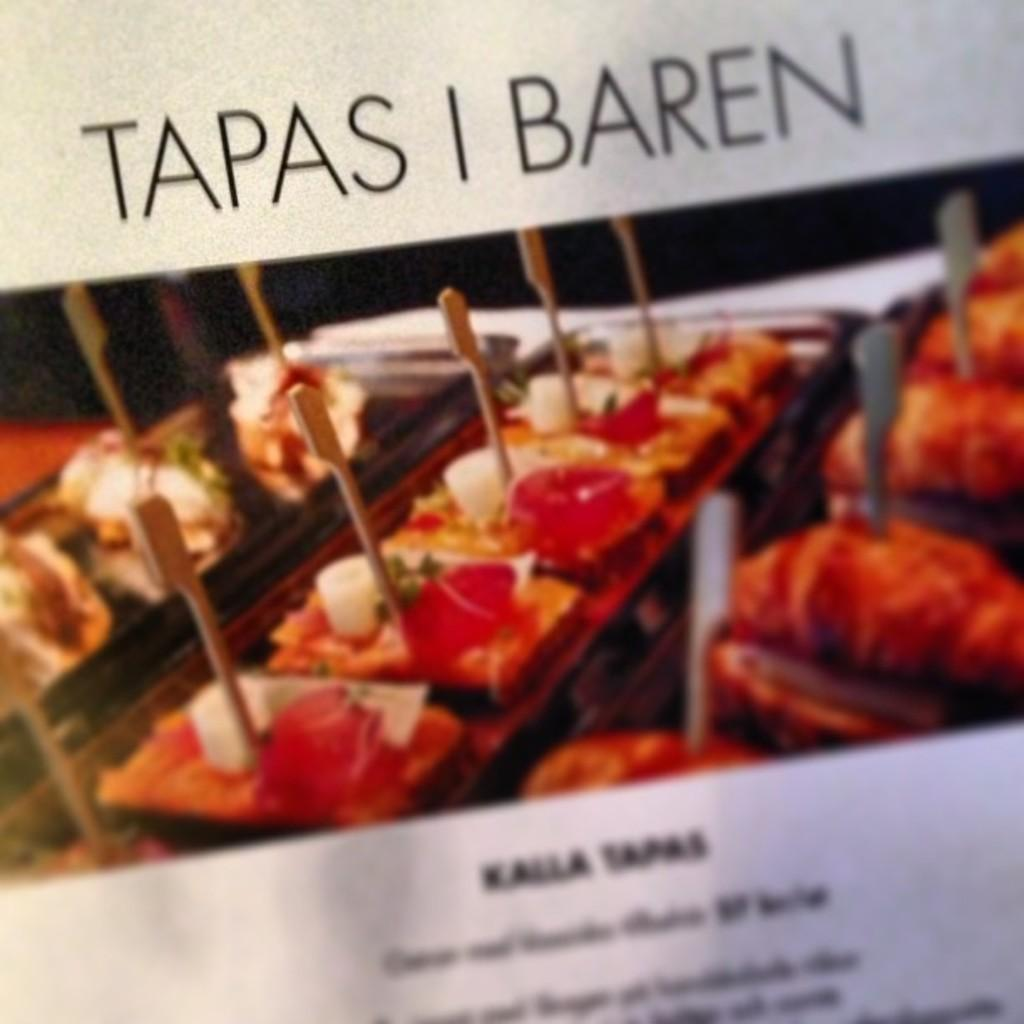What is featured on the poster in the image? There is a poster in the image that contains food items with sticks. What else can be seen on the poster besides the food items? There is text written on the poster. How long does it take for the iron to heat up in the image? There is no iron present in the image, so it is not possible to determine how long it would take to heat up. 